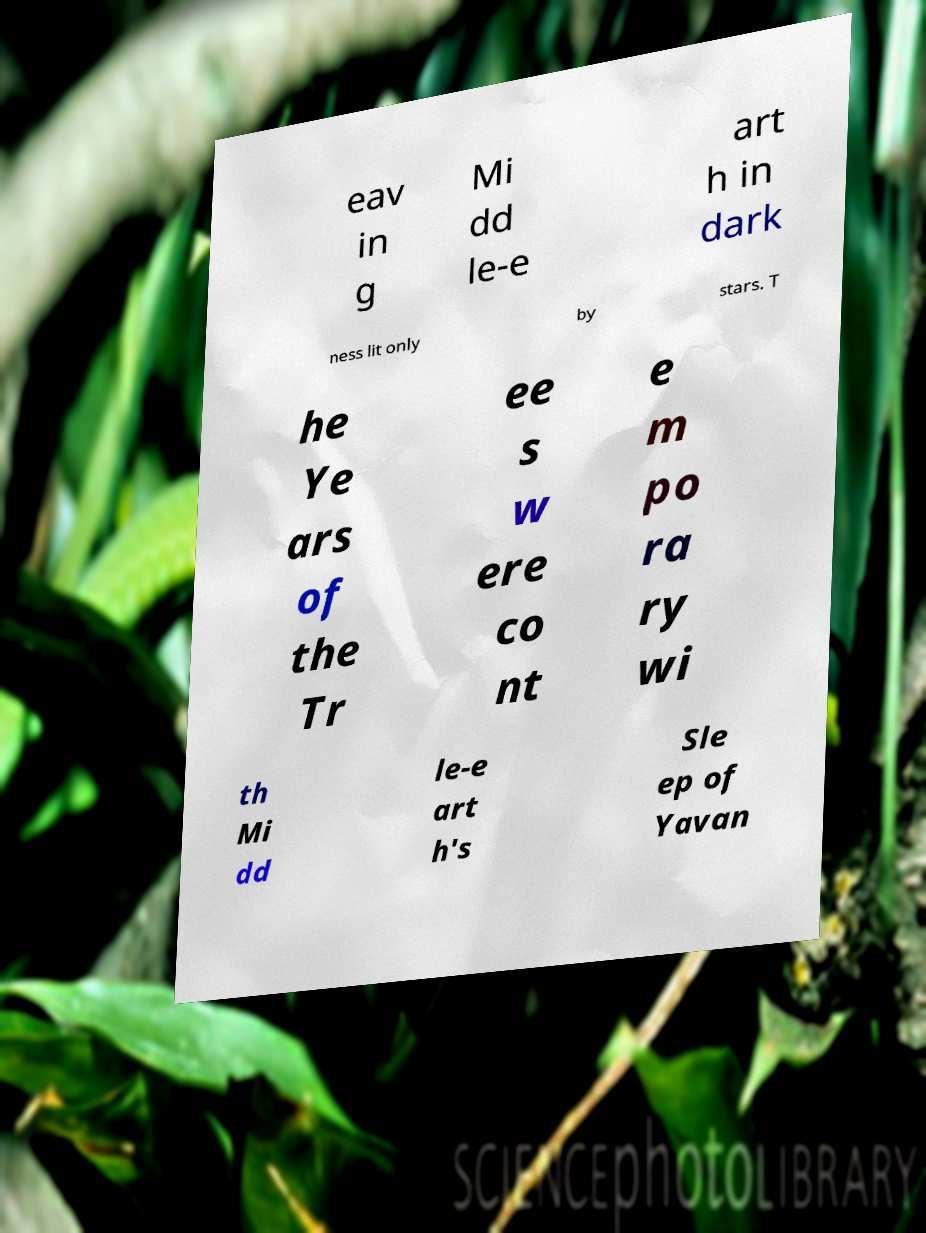Can you read and provide the text displayed in the image?This photo seems to have some interesting text. Can you extract and type it out for me? eav in g Mi dd le-e art h in dark ness lit only by stars. T he Ye ars of the Tr ee s w ere co nt e m po ra ry wi th Mi dd le-e art h's Sle ep of Yavan 